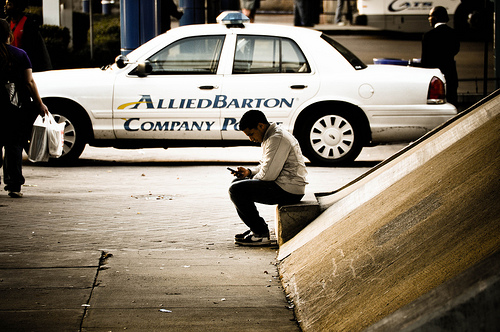What is the man sitting on? The man is sitting on a low concrete wall or bench, which is adjacent to an inclined surface extending upwards. What might the man be doing? The man appears to be engrossed in his phone, possibly texting someone, browsing the internet, or watching a video. Describe in detail what you see in the image. In the image, there is a man sitting on a low concrete wall. He is looking down at his phone, seemingly deep in concentration. Behind him, there's a parked company police vehicle with 'ALLIEDBARTON Company Police' written on the side. The area appears to be a sidewalk adjacent to some urban or commercial buildings or settings. Additionally, a person carrying bags is partially visible on the left side, indicative of either a shopping area or a place with high pedestrian traffic. Imagine a story involving this man. What could be happening? Once upon a time in the bustling city, a young man named Alex found a quiet corner to sit and catch his breath. As he scrolled through his phone, he was searching for a café where he could meet a friend he hadn't seen in years. Alex had just moved back into the city, and finding his way around familiar yet changed streets was a challenge. The nearby company police car stood as a reminder of the city's constant vigilance, though he paid it little heed. Lost in thoughts of reconnection and nostalgia, he didn't notice the passerby carrying bags, each on their own journey. What Alex didn't realize, as he typed '-I'm here, where are you?-’, was that this small moment was the beginning of an unforgettable day filled with laughter, memories, and a single spark of serendipity that would set his new path in motion. 